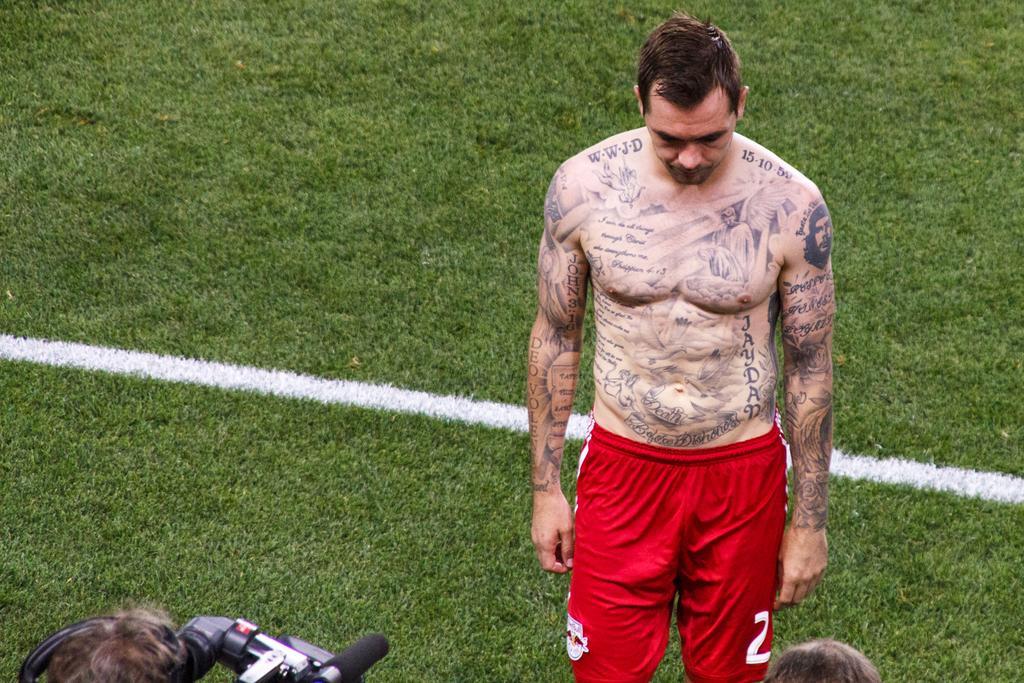In one or two sentences, can you explain what this image depicts? Land is covered with grass. Here we can see a person. On this person's body there are tattoos. This man is holding a camera with mic.  